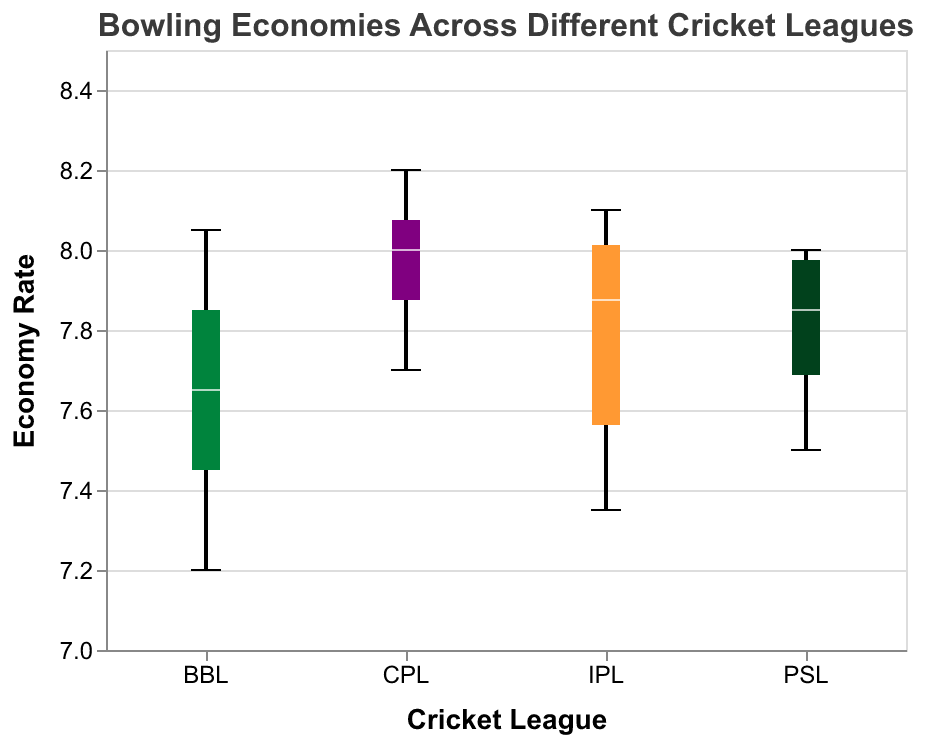What is the title of the figure? The title is located at the top of the figure, indicating the subject it represents. It reads "Bowling Economies Across Different Cricket Leagues."
Answer: Bowling Economies Across Different Cricket Leagues How many cricket leagues are represented in the figure? The x-axis of the figure shows the names of the cricket leagues, indicating the total number of different leagues represented. There are four different leagues: IPL, BBL, CPL, and PSL.
Answer: Four Which league has the lowest minimum economy rate? To determine the cricket league with the lowest minimum economy rate, look for the league with the lowest point at the bottom of its box plot. The BBL (Big Bash League) has the lowest minimum economy rate of 7.20.
Answer: BBL What is the median economy rate of IPL? The median value is shown as a white line inside each box plot. For the IPL, this white line is at approximately 7.85.
Answer: 7.85 Which team has the highest economy rate in the given data, and which league does it belong to? The highest points at the top of a box plot represent the maximum economy rate for each league. Observing these highest points, CPL (St Lucia Zouks) has the highest economy rate of 8.20.
Answer: St Lucia Zouks from CPL Compare the median economy rates of CPL and PSL. Which league has the higher median economy rate? Look at the white lines inside the box plots of CPL and PSL. CPL's median economy rate is around 8.00, whereas PSL's median economy rate is approximately 7.90. Thus, CPL has the higher median economy rate.
Answer: CPL What is the range of economy rates within the BBL league? The range of economy rates is found by subtracting the minimum value from the maximum value. The BBL has a minimum economy rate of 7.20 and a maximum of 8.05, giving a range of 8.05 - 7.20 = 0.85.
Answer: 0.85 Which league has the widest distribution of economy rates? Find the league where the distance between the top and bottom ends of the box plot (whiskers) is the largest. The CPL has a box plot range from 7.70 to 8.20, showing the widest distribution of economy rates.
Answer: CPL What is the interquartile range (IQR) of economy rates for IPL? The interquartile range is the difference between the third quartile (top edge of the box) and the first quartile (bottom edge of the box). For IPL, this range is from about 7.45 to 8.05, so the IQR is 8.05 - 7.45 = 0.60.
Answer: 0.60 